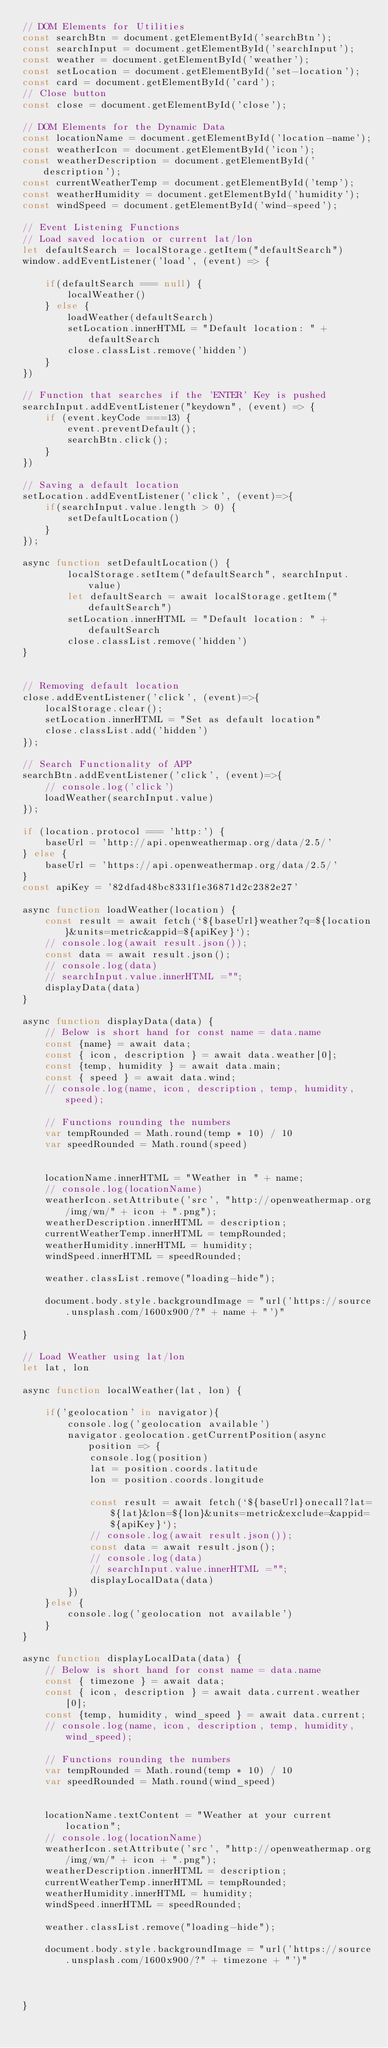Convert code to text. <code><loc_0><loc_0><loc_500><loc_500><_JavaScript_>// DOM Elements for Utilities
const searchBtn = document.getElementById('searchBtn');
const searchInput = document.getElementById('searchInput');
const weather = document.getElementById('weather');
const setLocation = document.getElementById('set-location');
const card = document.getElementById('card');
// Close button
const close = document.getElementById('close');

// DOM Elements for the Dynamic Data
const locationName = document.getElementById('location-name');
const weatherIcon = document.getElementById('icon');
const weatherDescription = document.getElementById('description');
const currentWeatherTemp = document.getElementById('temp');
const weatherHumidity = document.getElementById('humidity');
const windSpeed = document.getElementById('wind-speed');

// Event Listening Functions
// Load saved location or current lat/lon
let defaultSearch = localStorage.getItem("defaultSearch")
window.addEventListener('load', (event) => {
    
    if(defaultSearch === null) {
        localWeather()
    } else {
        loadWeather(defaultSearch)
        setLocation.innerHTML = "Default location: " + defaultSearch
        close.classList.remove('hidden')
    }
})

// Function that searches if the 'ENTER' Key is pushed
searchInput.addEventListener("keydown", (event) => {
    if (event.keyCode ===13) {
        event.preventDefault();
        searchBtn.click();
    }
})

// Saving a default location
setLocation.addEventListener('click', (event)=>{
    if(searchInput.value.length > 0) {
        setDefaultLocation()
    }
});

async function setDefaultLocation() {
        localStorage.setItem("defaultSearch", searchInput.value)
        let defaultSearch = await localStorage.getItem("defaultSearch")
        setLocation.innerHTML = "Default location: " + defaultSearch
        close.classList.remove('hidden')
}

    
// Removing default location
close.addEventListener('click', (event)=>{
    localStorage.clear();
    setLocation.innerHTML = "Set as default location"
    close.classList.add('hidden')
});

// Search Functionality of APP
searchBtn.addEventListener('click', (event)=>{
    // console.log('click')
    loadWeather(searchInput.value)
});

if (location.protocol === 'http:') {
    baseUrl = 'http://api.openweathermap.org/data/2.5/'
} else { 
    baseUrl = 'https://api.openweathermap.org/data/2.5/'
}
const apiKey = '82dfad48bc8331f1e36871d2c2382e27'

async function loadWeather(location) {
    const result = await fetch(`${baseUrl}weather?q=${location}&units=metric&appid=${apiKey}`);
    // console.log(await result.json());
    const data = await result.json();
    // console.log(data)
    // searchInput.value.innerHTML ="";
    displayData(data)
}

async function displayData(data) {
    // Below is short hand for const name = data.name
    const {name} = await data;
    const { icon, description } = await data.weather[0];
    const {temp, humidity } = await data.main;
    const { speed } = await data.wind;
    // console.log(name, icon, description, temp, humidity, speed);

    // Functions rounding the numbers
    var tempRounded = Math.round(temp * 10) / 10
    var speedRounded = Math.round(speed)


    locationName.innerHTML = "Weather in " + name;
    // console.log(locationName)
    weatherIcon.setAttribute('src', "http://openweathermap.org/img/wn/" + icon + ".png");
    weatherDescription.innerHTML = description;
    currentWeatherTemp.innerHTML = tempRounded;
    weatherHumidity.innerHTML = humidity;
    windSpeed.innerHTML = speedRounded;

    weather.classList.remove("loading-hide");

    document.body.style.backgroundImage = "url('https://source.unsplash.com/1600x900/?" + name + "')"

}

// Load Weather using lat/lon
let lat, lon

async function localWeather(lat, lon) {

    if('geolocation' in navigator){
        console.log('geolocation available')
        navigator.geolocation.getCurrentPosition(async position => {
            console.log(position)
            lat = position.coords.latitude
            lon = position.coords.longitude

            const result = await fetch(`${baseUrl}onecall?lat=${lat}&lon=${lon}&units=metric&exclude=&appid=${apiKey}`);
            // console.log(await result.json());
            const data = await result.json();
            // console.log(data)
            // searchInput.value.innerHTML ="";
            displayLocalData(data)
        })
    }else {
        console.log('geolocation not available')
    }
}

async function displayLocalData(data) {
    // Below is short hand for const name = data.name
    const { timezone } = await data;
    const { icon, description } = await data.current.weather[0];
    const {temp, humidity, wind_speed } = await data.current; 
    // console.log(name, icon, description, temp, humidity, wind_speed);

    // Functions rounding the numbers
    var tempRounded = Math.round(temp * 10) / 10
    var speedRounded = Math.round(wind_speed)


    locationName.textContent = "Weather at your current location";
    // console.log(locationName)
    weatherIcon.setAttribute('src', "http://openweathermap.org/img/wn/" + icon + ".png");
    weatherDescription.innerHTML = description;
    currentWeatherTemp.innerHTML = tempRounded;
    weatherHumidity.innerHTML = humidity;
    windSpeed.innerHTML = speedRounded;

    weather.classList.remove("loading-hide");

    document.body.style.backgroundImage = "url('https://source.unsplash.com/1600x900/?" + timezone + "')"

    

}

</code> 